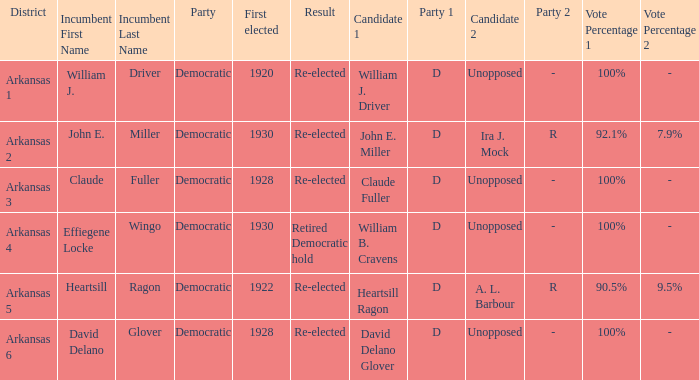Who ran in the election where Claude Fuller was the incumbent?  Claude Fuller (D) Unopposed. Could you help me parse every detail presented in this table? {'header': ['District', 'Incumbent First Name', 'Incumbent Last Name', 'Party', 'First elected', 'Result', 'Candidate 1', 'Party 1', 'Candidate 2', 'Party 2', 'Vote Percentage 1', 'Vote Percentage 2'], 'rows': [['Arkansas 1', 'William J.', 'Driver', 'Democratic', '1920', 'Re-elected', 'William J. Driver', 'D', 'Unopposed', '-', '100%', '-'], ['Arkansas 2', 'John E.', 'Miller', 'Democratic', '1930', 'Re-elected', 'John E. Miller', 'D', 'Ira J. Mock', 'R', '92.1%', '7.9%'], ['Arkansas 3', 'Claude', 'Fuller', 'Democratic', '1928', 'Re-elected', 'Claude Fuller', 'D', 'Unopposed', '-', '100%', '-'], ['Arkansas 4', 'Effiegene Locke', 'Wingo', 'Democratic', '1930', 'Retired Democratic hold', 'William B. Cravens', 'D', 'Unopposed', '-', '100%', '-'], ['Arkansas 5', 'Heartsill', 'Ragon', 'Democratic', '1922', 'Re-elected', 'Heartsill Ragon', 'D', 'A. L. Barbour', 'R', '90.5%', '9.5%'], ['Arkansas 6', 'David Delano', 'Glover', 'Democratic', '1928', 'Re-elected', 'David Delano Glover', 'D', 'Unopposed', '-', '100%', '-']]} 